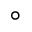<formula> <loc_0><loc_0><loc_500><loc_500>^ { \circ }</formula> 